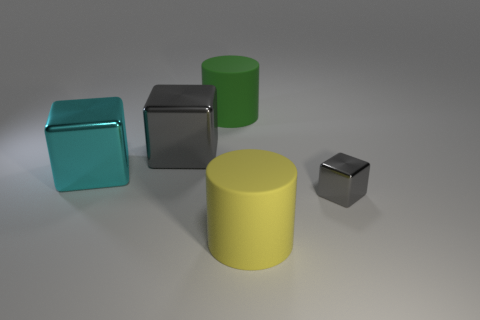Add 2 gray things. How many objects exist? 7 Subtract all cylinders. How many objects are left? 3 Subtract 0 red cylinders. How many objects are left? 5 Subtract all tiny purple matte objects. Subtract all large cyan things. How many objects are left? 4 Add 1 gray shiny objects. How many gray shiny objects are left? 3 Add 2 large cyan things. How many large cyan things exist? 3 